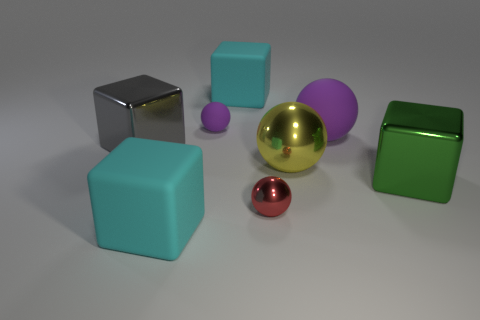Subtract 1 balls. How many balls are left? 3 Add 2 blue matte cubes. How many objects exist? 10 Add 5 large yellow spheres. How many large yellow spheres are left? 6 Add 8 large cyan blocks. How many large cyan blocks exist? 10 Subtract 0 brown cylinders. How many objects are left? 8 Subtract all yellow metallic spheres. Subtract all yellow things. How many objects are left? 6 